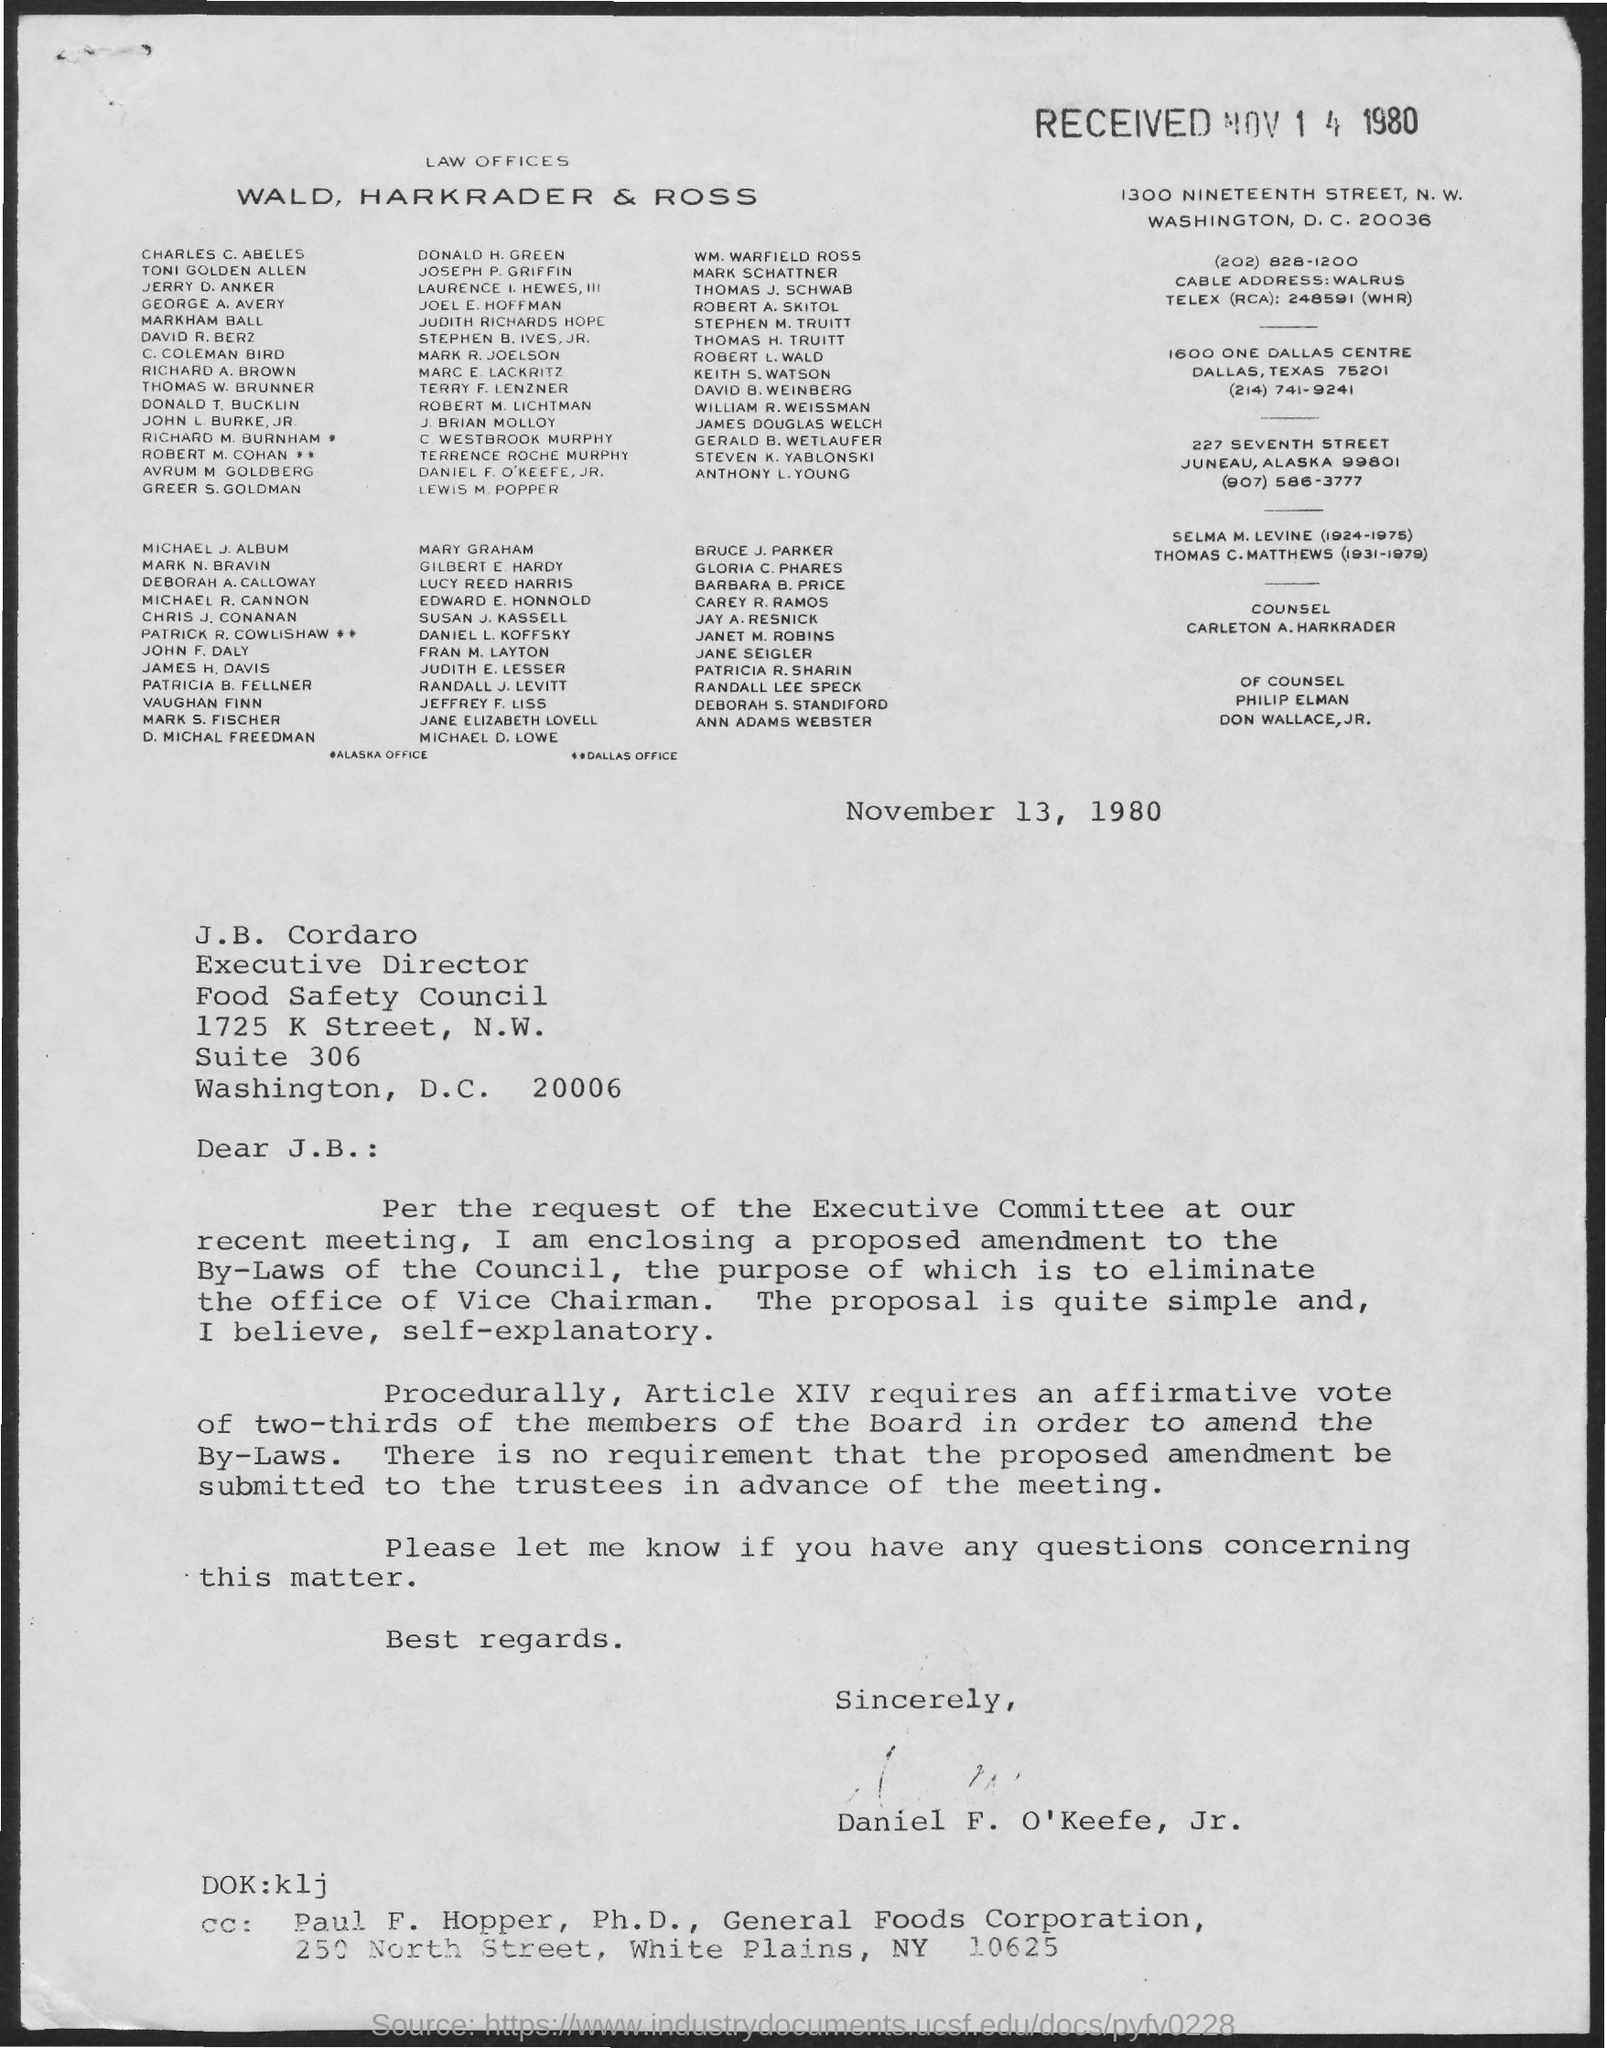Specify some key components in this picture. The letter is dated November 13, 1980. 